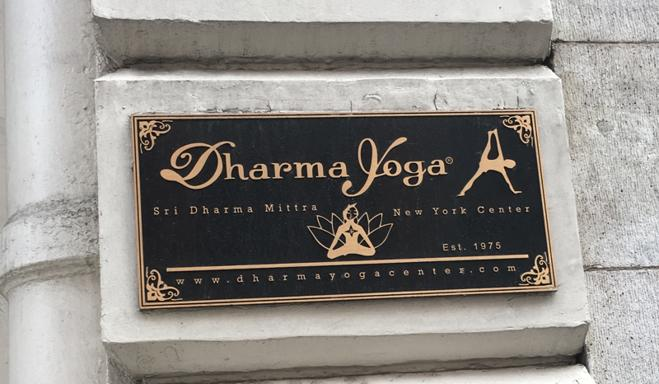What is written on the sign in the image? The sign prominently displays 'Dharma Yoga', with the subtitle 'Sri Dharma Mittra New York Center' underneath. It also features an establishment date, 'Est. 1975', and a website, 'www.dharmayogacenter.com'. The 'A' forms part of the logo itself. 